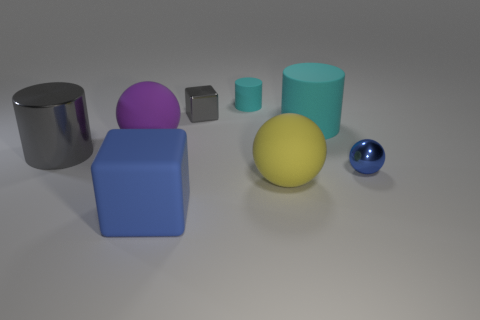Is the shape of the gray metallic thing behind the big cyan matte cylinder the same as  the large blue thing?
Your answer should be very brief. Yes. There is a cyan object that is the same size as the shiny cube; what is its material?
Provide a succinct answer. Rubber. Are there any large things made of the same material as the tiny cyan object?
Your response must be concise. Yes. Is the shape of the large blue matte thing the same as the shiny thing that is behind the large gray shiny cylinder?
Provide a short and direct response. Yes. How many objects are in front of the tiny metal ball and left of the big purple thing?
Provide a short and direct response. 0. Is the small cyan thing made of the same material as the blue thing that is to the right of the yellow sphere?
Your answer should be compact. No. Are there an equal number of big purple things right of the tiny matte thing and tiny cyan spheres?
Your response must be concise. Yes. There is a cube in front of the big yellow matte ball; what is its color?
Keep it short and to the point. Blue. How many other objects are there of the same color as the metal block?
Your response must be concise. 1. Are there any other things that are the same size as the metal cylinder?
Your answer should be compact. Yes. 